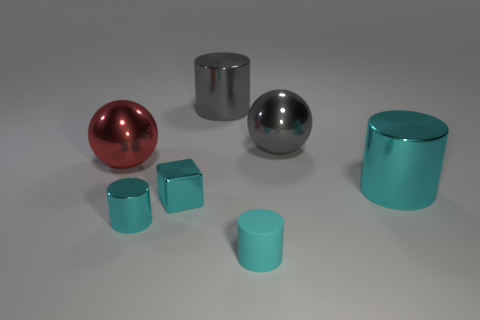Are there any cyan shiny cubes on the left side of the small thing that is behind the cyan metallic cylinder left of the cyan matte cylinder?
Provide a short and direct response. No. Do the shiny thing that is in front of the tiny cube and the tiny matte object have the same shape?
Ensure brevity in your answer.  Yes. What color is the block that is the same material as the red thing?
Ensure brevity in your answer.  Cyan. How many small blocks are the same material as the big gray sphere?
Your answer should be compact. 1. There is a large thing in front of the sphere to the left of the cyan metal cylinder that is in front of the cyan cube; what color is it?
Give a very brief answer. Cyan. Does the shiny cube have the same size as the cyan matte thing?
Give a very brief answer. Yes. Is there any other thing that is the same shape as the small cyan rubber object?
Offer a terse response. Yes. How many objects are metal objects on the right side of the small cyan shiny cylinder or tiny cyan rubber cylinders?
Your answer should be compact. 5. Do the red metal object and the big cyan thing have the same shape?
Provide a succinct answer. No. How many other things are the same size as the cyan matte cylinder?
Provide a succinct answer. 2. 